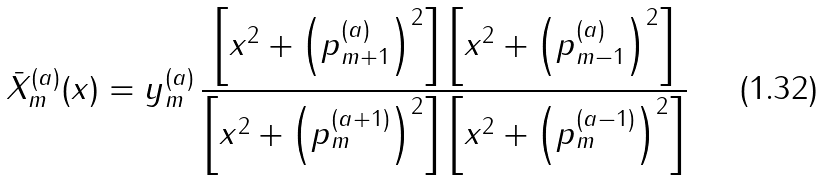<formula> <loc_0><loc_0><loc_500><loc_500>\bar { X } ^ { ( a ) } _ { m } ( x ) = y ^ { ( a ) } _ { m } \, \frac { \left [ x ^ { 2 } + \left ( p ^ { ( a ) } _ { m + 1 } \right ) ^ { 2 } \right ] \left [ x ^ { 2 } + \left ( p ^ { ( a ) } _ { m - 1 } \right ) ^ { 2 } \right ] } { \left [ x ^ { 2 } + \left ( p ^ { ( a + 1 ) } _ { m } \right ) ^ { 2 } \right ] \left [ x ^ { 2 } + \left ( p ^ { ( a - 1 ) } _ { m } \right ) ^ { 2 } \right ] }</formula> 